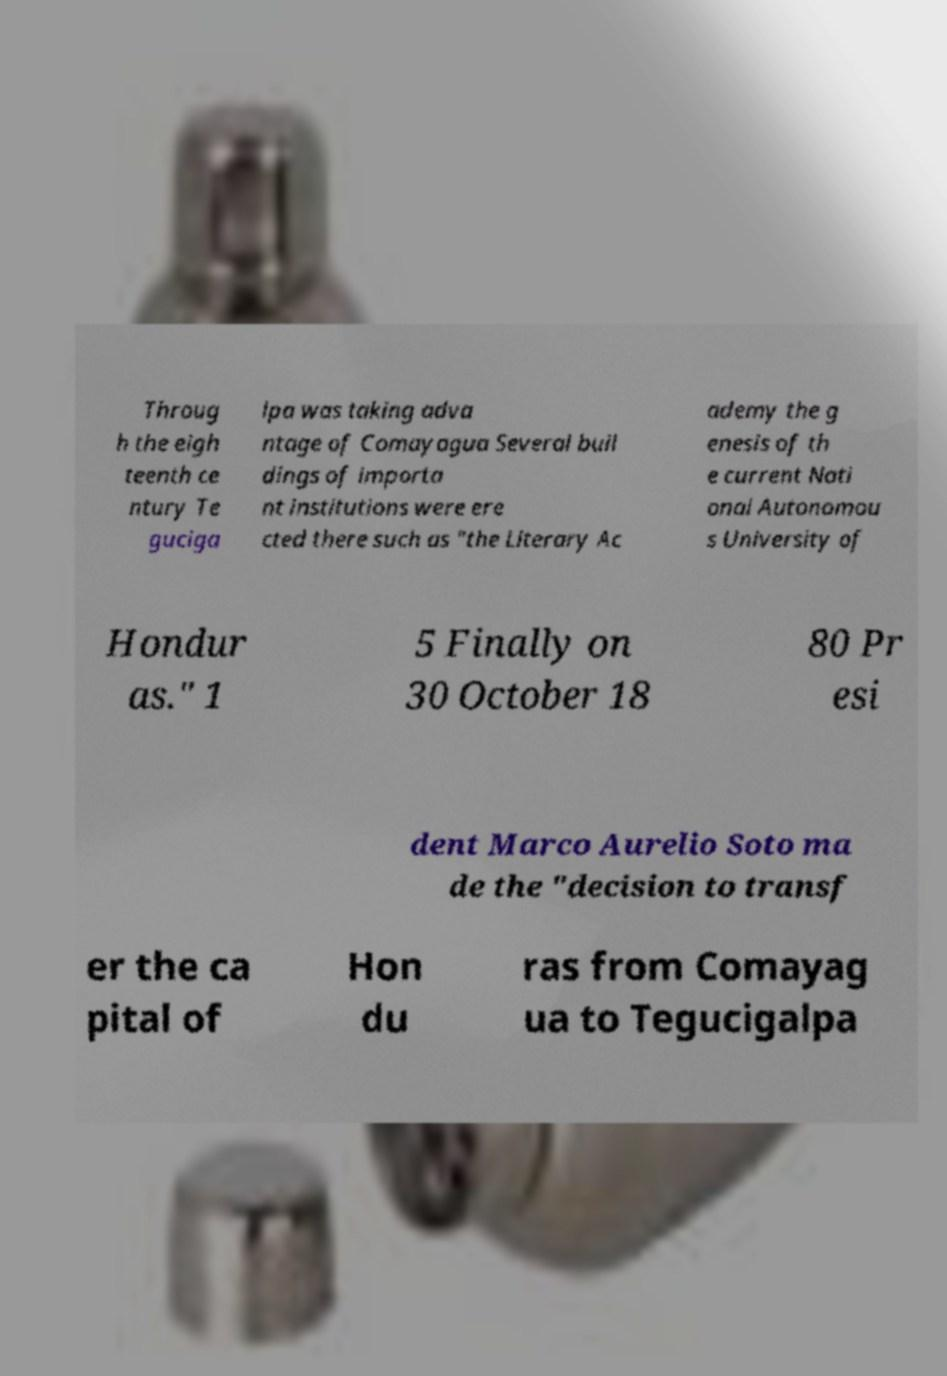There's text embedded in this image that I need extracted. Can you transcribe it verbatim? Throug h the eigh teenth ce ntury Te guciga lpa was taking adva ntage of Comayagua Several buil dings of importa nt institutions were ere cted there such as "the Literary Ac ademy the g enesis of th e current Nati onal Autonomou s University of Hondur as." 1 5 Finally on 30 October 18 80 Pr esi dent Marco Aurelio Soto ma de the "decision to transf er the ca pital of Hon du ras from Comayag ua to Tegucigalpa 